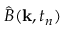<formula> <loc_0><loc_0><loc_500><loc_500>\hat { B } ( k , t _ { n } )</formula> 